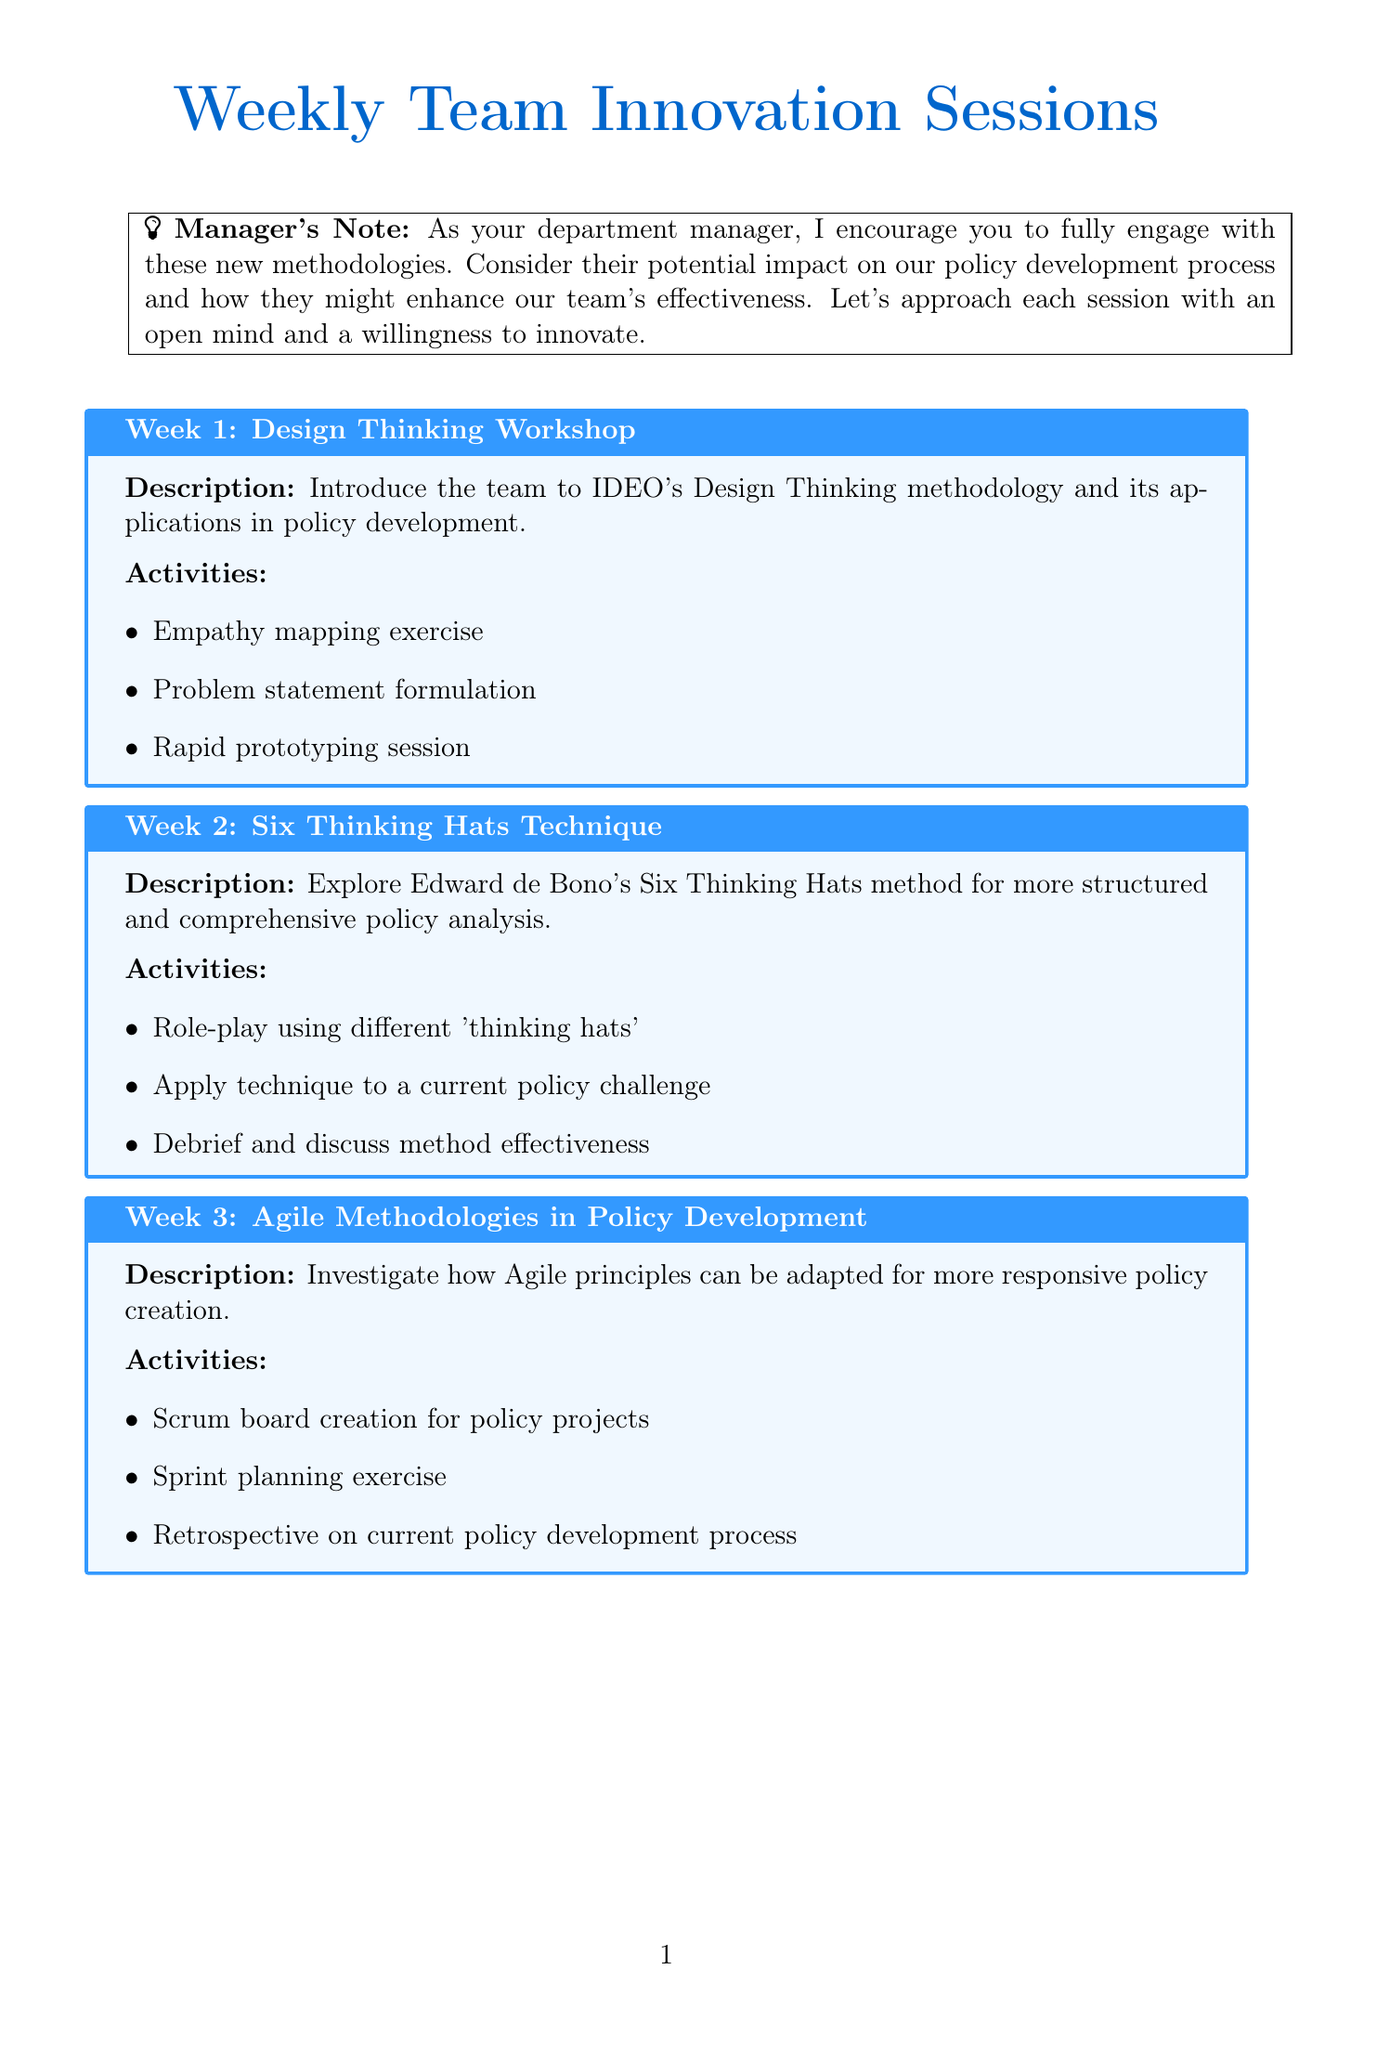What is the topic of Week 1? The topic for Week 1 is listed as "Design Thinking Workshop" in the schedule.
Answer: Design Thinking Workshop What is the expected outcome of Week 4? The expected outcome for Week 4 involves analyzing and communicating complex policy interactions.
Answer: Enhanced ability to analyze and communicate complex policy interactions Which methodology is explored in Week 6? The methodology discussed in Week 6 is related to behavioral economics and its application in policy, specifically "Nudge Theory."
Answer: Nudge Theory How many activities are planned for Week 3? The number of activities listed for Week 3 includes three distinct activities: creating a Scrum board, sprint planning, and a retrospective.
Answer: 3 What type of analysis is conducted in Week 5? The analysis type conducted in Week 5 is referred to as "PESTLE analysis."
Answer: PESTLE analysis What does the manager encourage the team to do? The manager encourages the team to engage fully with the methodologies presented in the sessions.
Answer: Engage with the methodologies What is the main focus of Week 2? The main focus of Week 2 is to explore the Six Thinking Hats technique for policy analysis.
Answer: Six Thinking Hats technique How many weeks are included in the innovation sessions? The total number of weeks detailed in the innovation sessions is eight, covering various topics and activities.
Answer: 8 